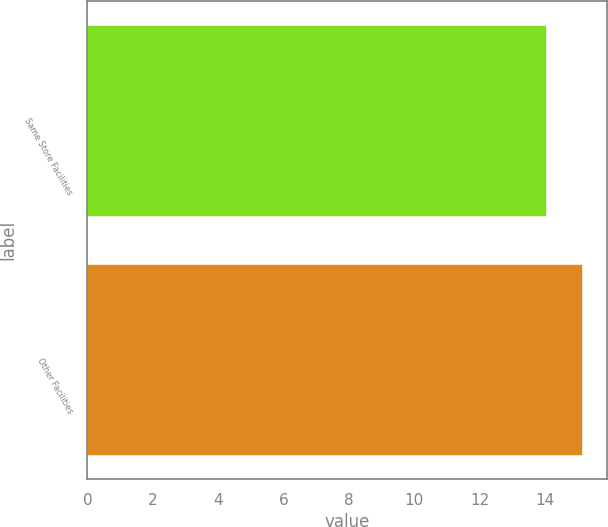<chart> <loc_0><loc_0><loc_500><loc_500><bar_chart><fcel>Same Store Facilities<fcel>Other Facilities<nl><fcel>14.02<fcel>15.14<nl></chart> 